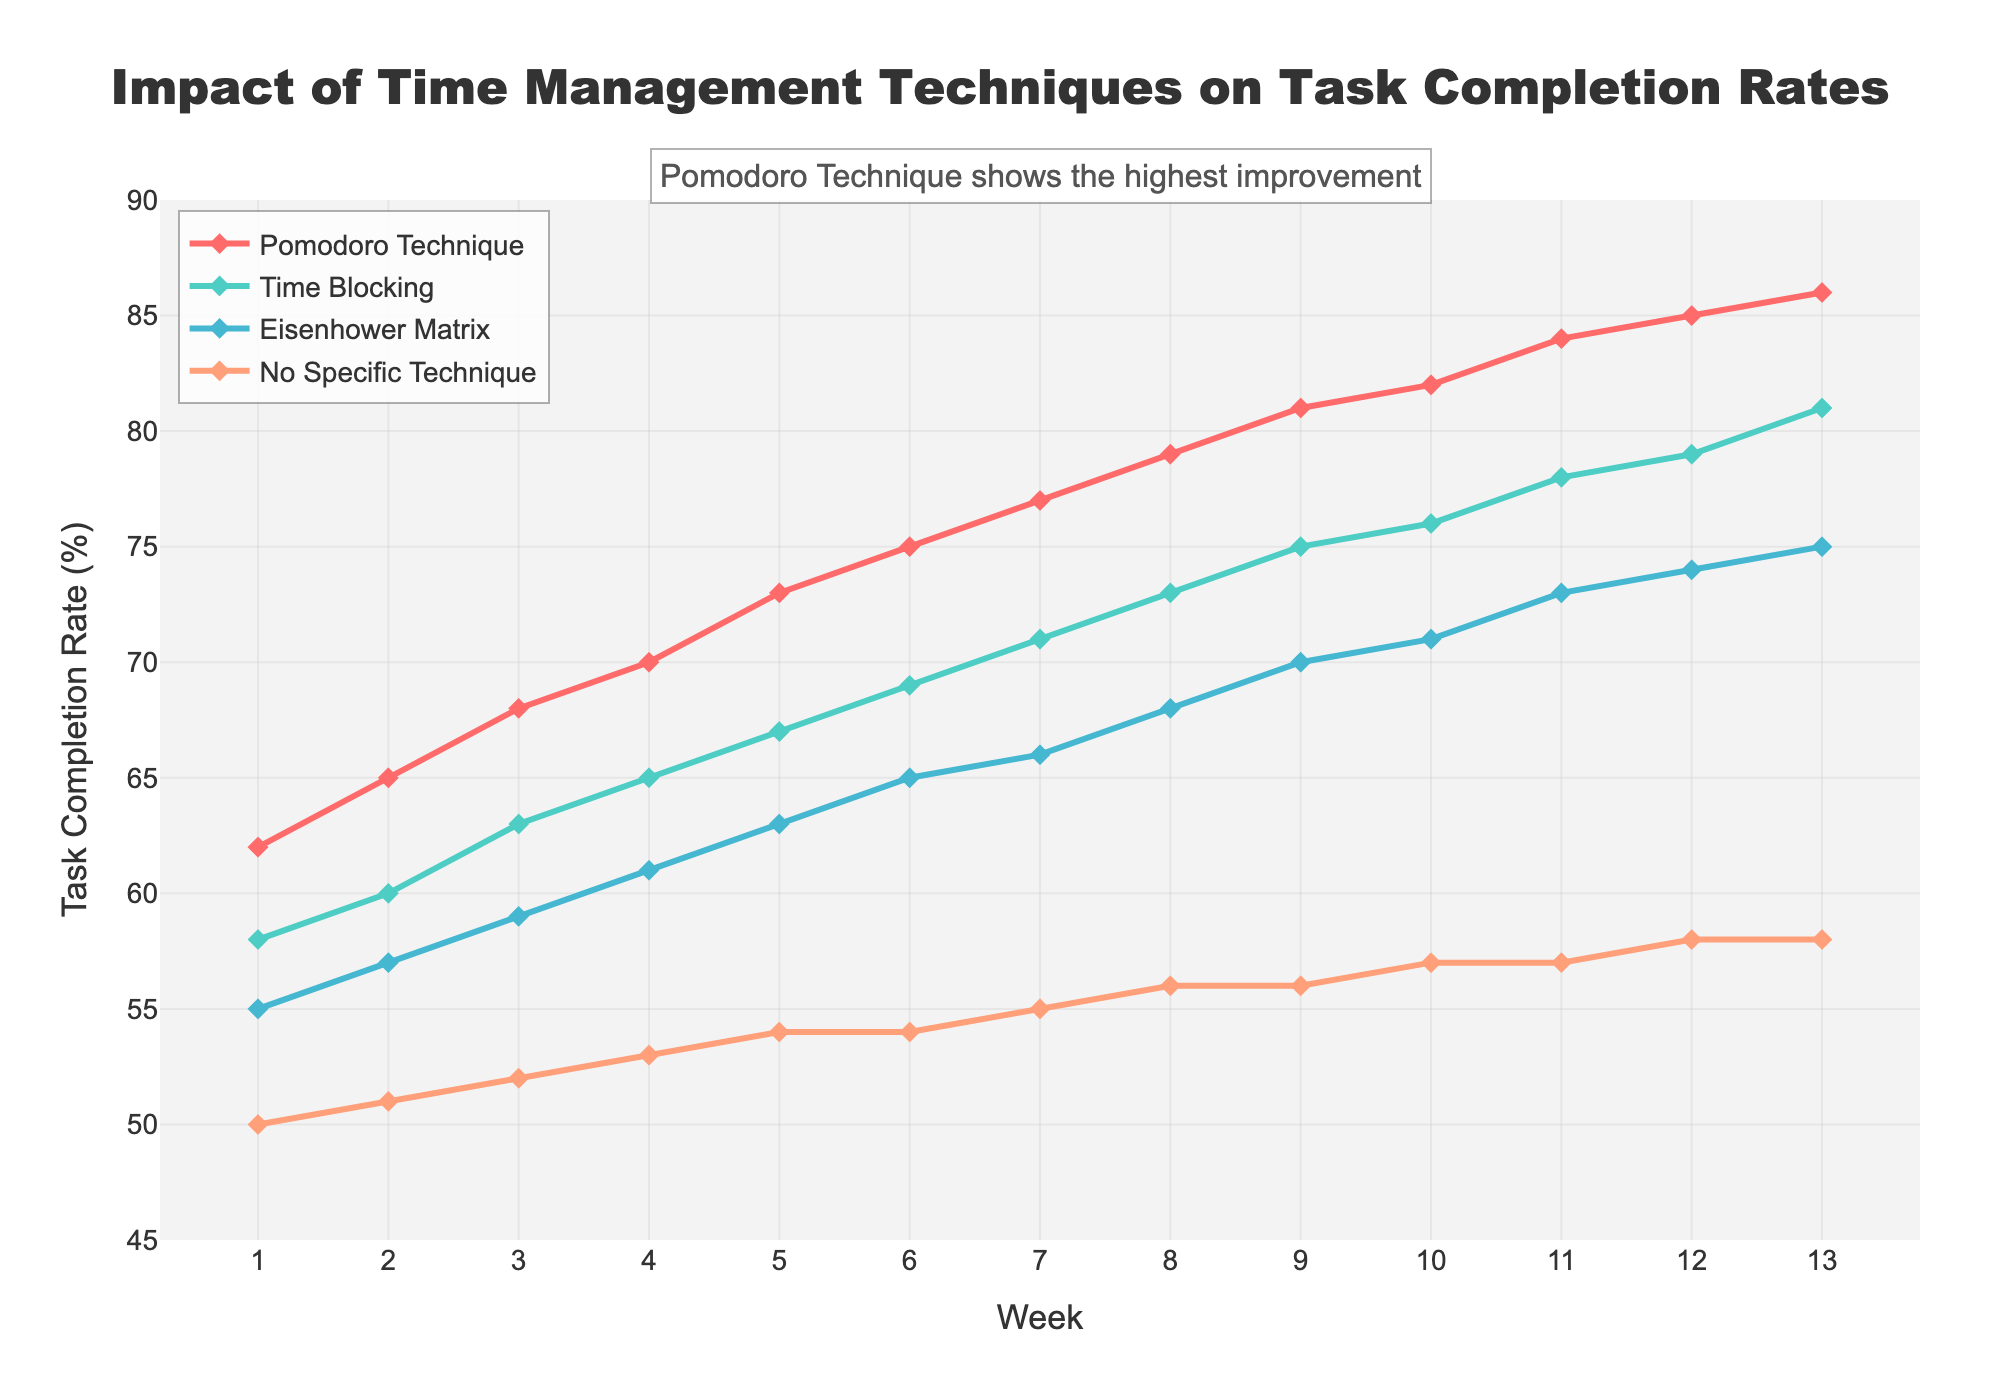What is the task completion rate for the Pomodoro Technique in week 5? To find the task completion rate for the Pomodoro Technique in week 5, simply refer to the Pomodoro Technique line on the chart and find the corresponding value for week 5. The data provided shows 73%.
Answer: 73% Which technique had the highest task completion rate in week 8? First, locate week 8 on the x-axis, then compare the heights of all lines (Pomodoro Technique, Time Blocking, Eisenhower Matrix, No Specific Technique) at this week. The Pomodoro Technique has the highest value at 79%.
Answer: Pomodoro Technique How does the task completion rate of Time Blocking compare between week 1 and week 12? Locate week 1 and week 12 on the x-axis and observe the task completion rate for Time Blocking at these points. In week 1, the rate is 58%, and in week 12, it is 79%. The increase is 79% - 58% = 21%.
Answer: Increased by 21% What is the difference in task completion rates between the Eisenhower Matrix and No Specific Technique in week 10? Look at the respective task completion rates for the Eisenhower Matrix and No Specific Technique at week 10. Eisenhower Matrix is at 71% and No Specific Technique is at 57%. The difference is 71% - 57% = 14%.
Answer: 14% Which technique shows the most consistent increase in task completion rates over the 13 weeks? To determine the consistency of the increase, observe the smoothness and linearity of the trend lines. The Pomodoro Technique line increases most consistently and smoothly without major fluctuations.
Answer: Pomodoro Technique By how much did the task completion rate improve for the Eisenhower Matrix from week 6 to week 9? Refer to the Eisenhower Matrix line and compare the task completion rates at week 6 (65%) and week 9 (70%). The improvement is 70% - 65% = 5%.
Answer: 5% At which weeks do Time Blocking and Eisenhower Matrix techniques have the same task completion rate? Compare the lines for Time Blocking and Eisenhower Matrix to find the points where they intersect. They intersect around week 7, both at 71%.
Answer: Week 7 What is the average task completion rate for No Specific Technique over the quarter? Sum the task completion rates for No Specific Technique from week 1 to week 13 and divide by the number of weeks. The total is 50 + 51 + 52 + 53 + 54 + 54 + 55 + 56 + 56 + 57 + 57 + 58 + 58 = 661. The average is 661 / 13 ≈ 50.9.
Answer: 50.9% Which technique reaches a task completion rate of 80% first? Identify the week at which each technique reaches 80%. The Pomodoro Technique reaches 80% at week 11. Other techniques do not reach 80% within the 13 weeks.
Answer: Pomodoro Technique 